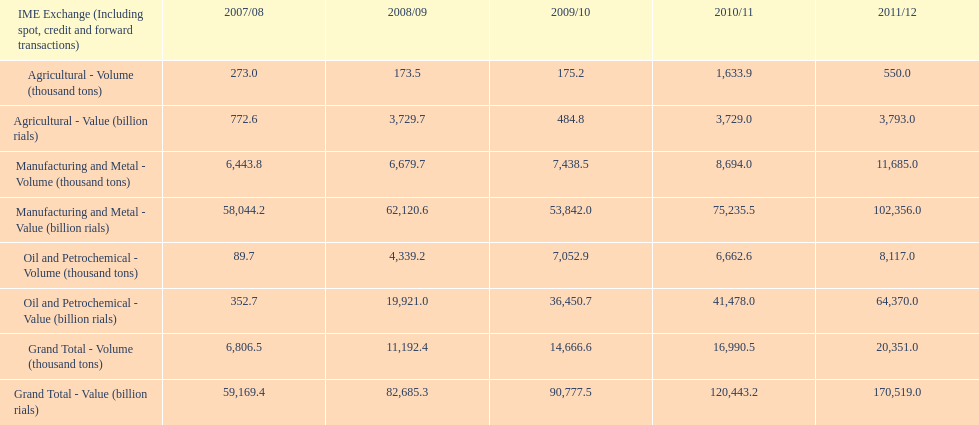Which year had the largest agricultural volume? 2010/11. 